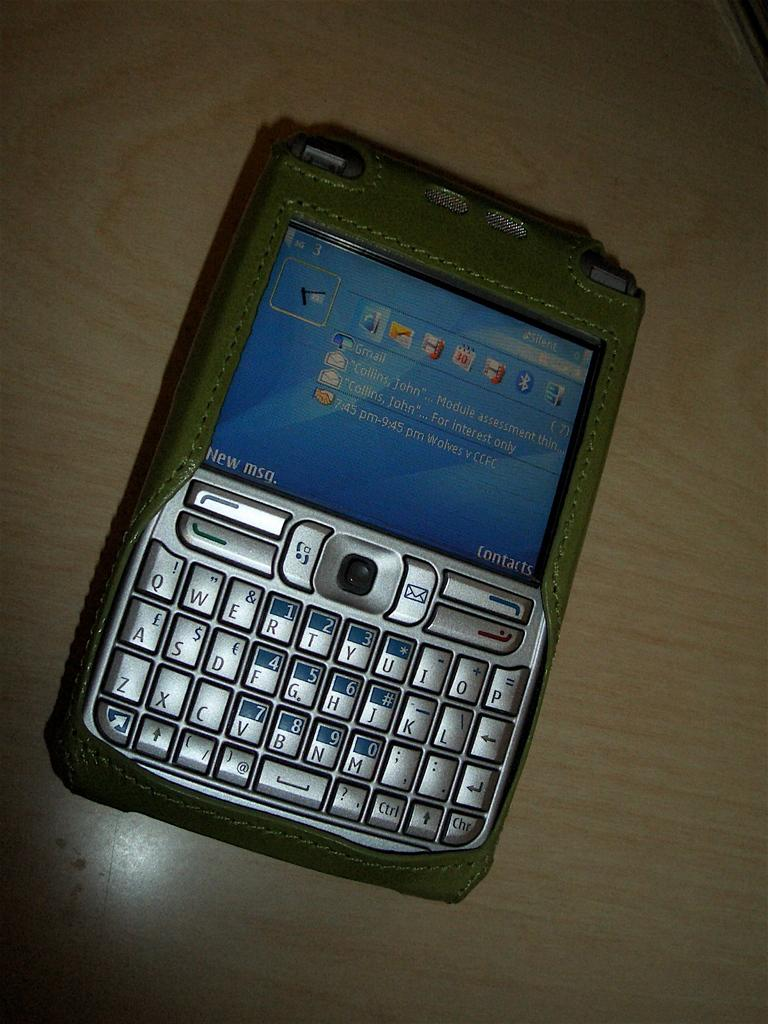Provide a one-sentence caption for the provided image. A user's Gmail account is visible on their cell phone screen. 